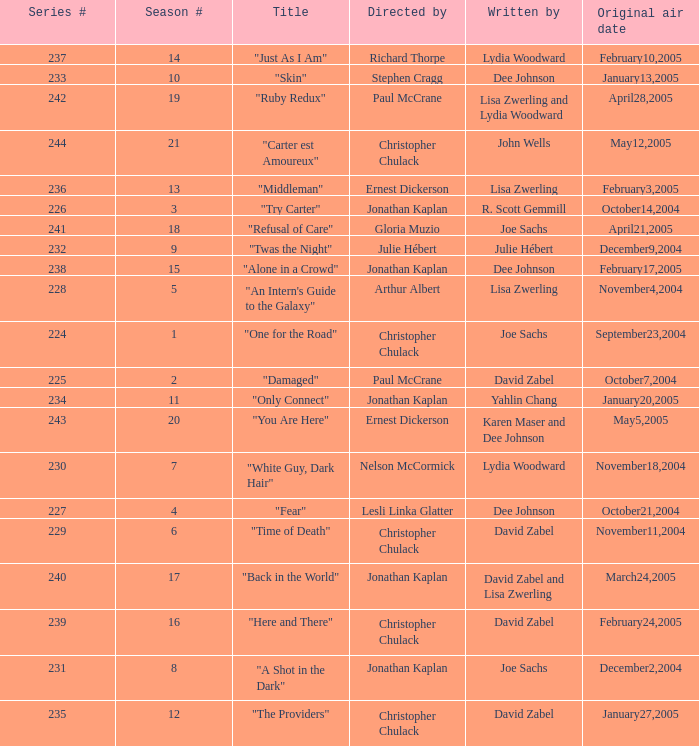Name the title that was written by r. scott gemmill "Try Carter". 